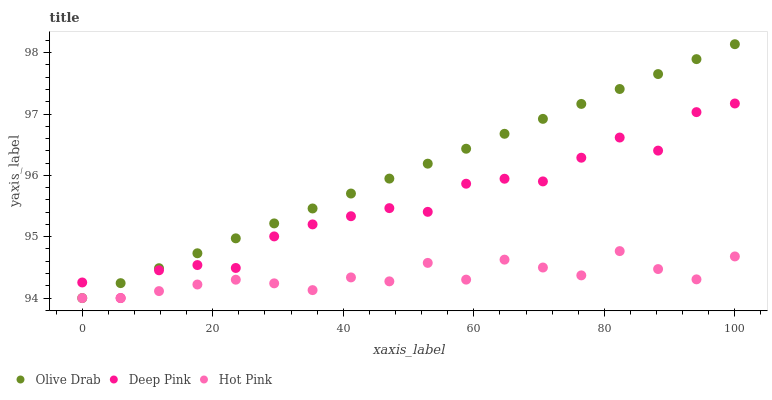Does Hot Pink have the minimum area under the curve?
Answer yes or no. Yes. Does Olive Drab have the maximum area under the curve?
Answer yes or no. Yes. Does Olive Drab have the minimum area under the curve?
Answer yes or no. No. Does Hot Pink have the maximum area under the curve?
Answer yes or no. No. Is Olive Drab the smoothest?
Answer yes or no. Yes. Is Deep Pink the roughest?
Answer yes or no. Yes. Is Hot Pink the smoothest?
Answer yes or no. No. Is Hot Pink the roughest?
Answer yes or no. No. Does Deep Pink have the lowest value?
Answer yes or no. Yes. Does Olive Drab have the highest value?
Answer yes or no. Yes. Does Hot Pink have the highest value?
Answer yes or no. No. Does Olive Drab intersect Hot Pink?
Answer yes or no. Yes. Is Olive Drab less than Hot Pink?
Answer yes or no. No. Is Olive Drab greater than Hot Pink?
Answer yes or no. No. 